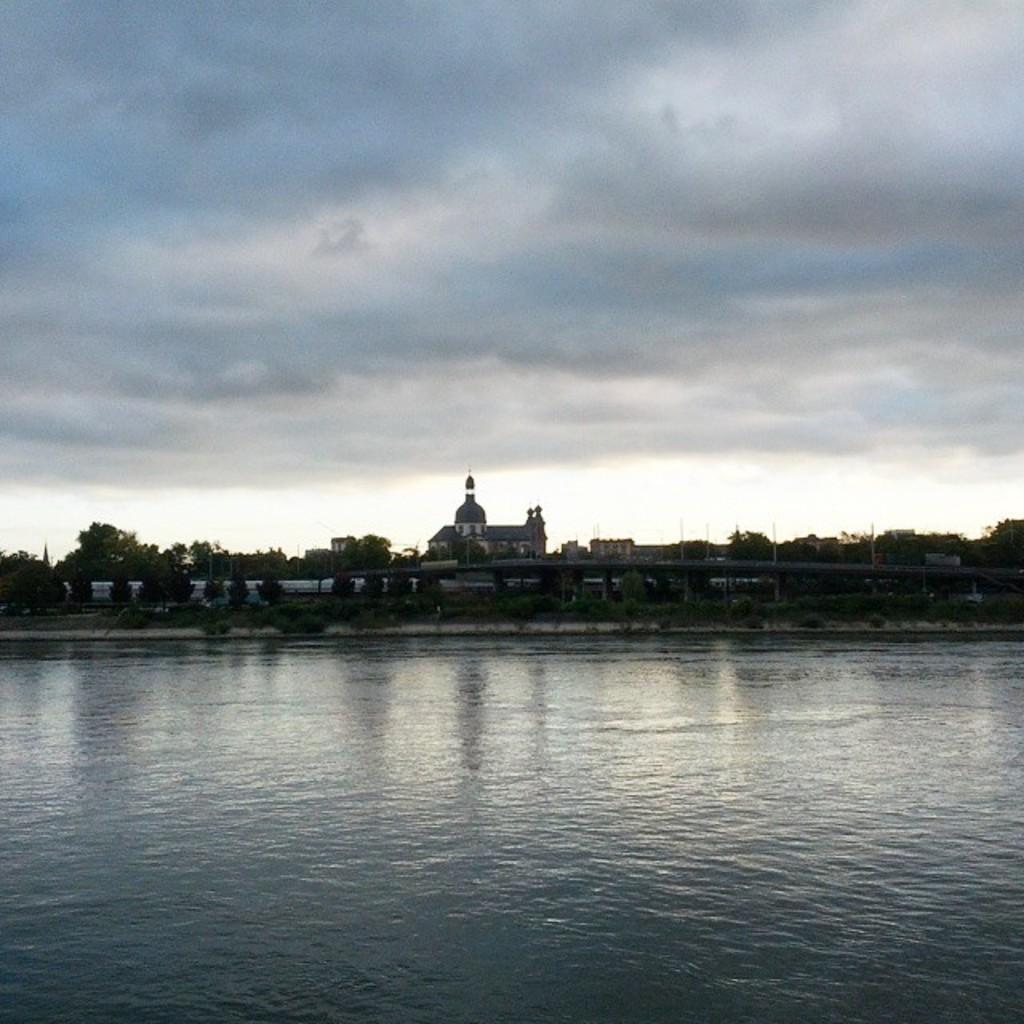Can you describe this image briefly? In this image I can see the water. To the side of the water I can see many trees, bridge and the buildings. In the background there are clouds and the sky. 